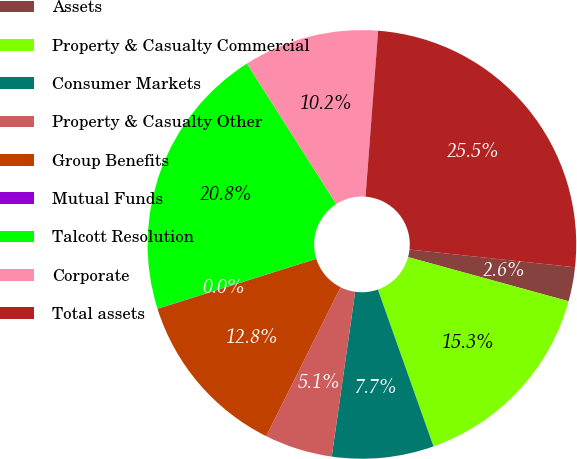Convert chart. <chart><loc_0><loc_0><loc_500><loc_500><pie_chart><fcel>Assets<fcel>Property & Casualty Commercial<fcel>Consumer Markets<fcel>Property & Casualty Other<fcel>Group Benefits<fcel>Mutual Funds<fcel>Talcott Resolution<fcel>Corporate<fcel>Total assets<nl><fcel>2.57%<fcel>15.31%<fcel>7.67%<fcel>5.12%<fcel>12.76%<fcel>0.03%<fcel>20.83%<fcel>10.22%<fcel>25.5%<nl></chart> 